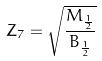<formula> <loc_0><loc_0><loc_500><loc_500>Z _ { 7 } = \sqrt { \frac { M _ { \frac { 1 } { 2 } } } { B _ { \frac { 1 } { 2 } } } }</formula> 